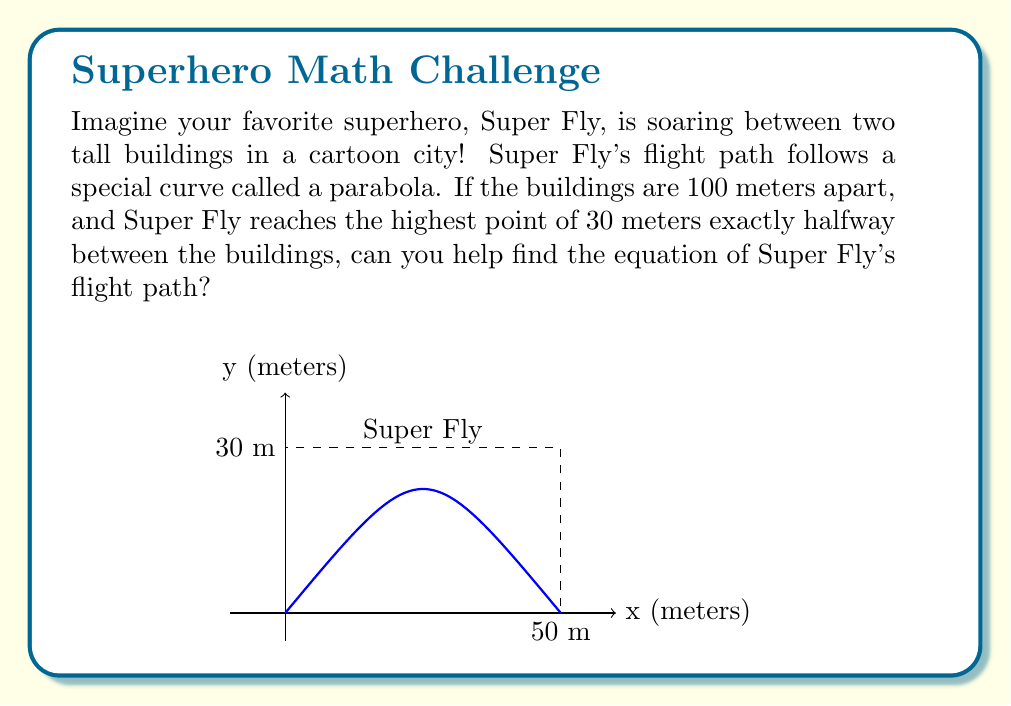Provide a solution to this math problem. Let's help Super Fly find the equation of their flight path! We'll use a step-by-step approach:

1) The general form of a parabola is:
   $$y = a(x-h)^2 + k$$
   where (h,k) is the vertex of the parabola.

2) We know the highest point (vertex) is halfway between the buildings and 30 meters high. So:
   h = 50 meters (half of 100)
   k = 30 meters

3) We can substitute these values:
   $$y = a(x-50)^2 + 30$$

4) To find 'a', we need another point. We know that when Super Fly is at either building, y = 0. Let's use x = 0:
   $$0 = a(0-50)^2 + 30$$
   $$0 = a(2500) + 30$$
   $$-30 = 2500a$$
   $$a = -\frac{30}{2500} = -\frac{3}{250} = -0.012$$

5) Now we have all parts of our equation:
   $$y = -0.012(x-50)^2 + 30$$

This equation describes Super Fly's amazing flight path between the buildings!
Answer: $$y = -0.012(x-50)^2 + 30$$ 